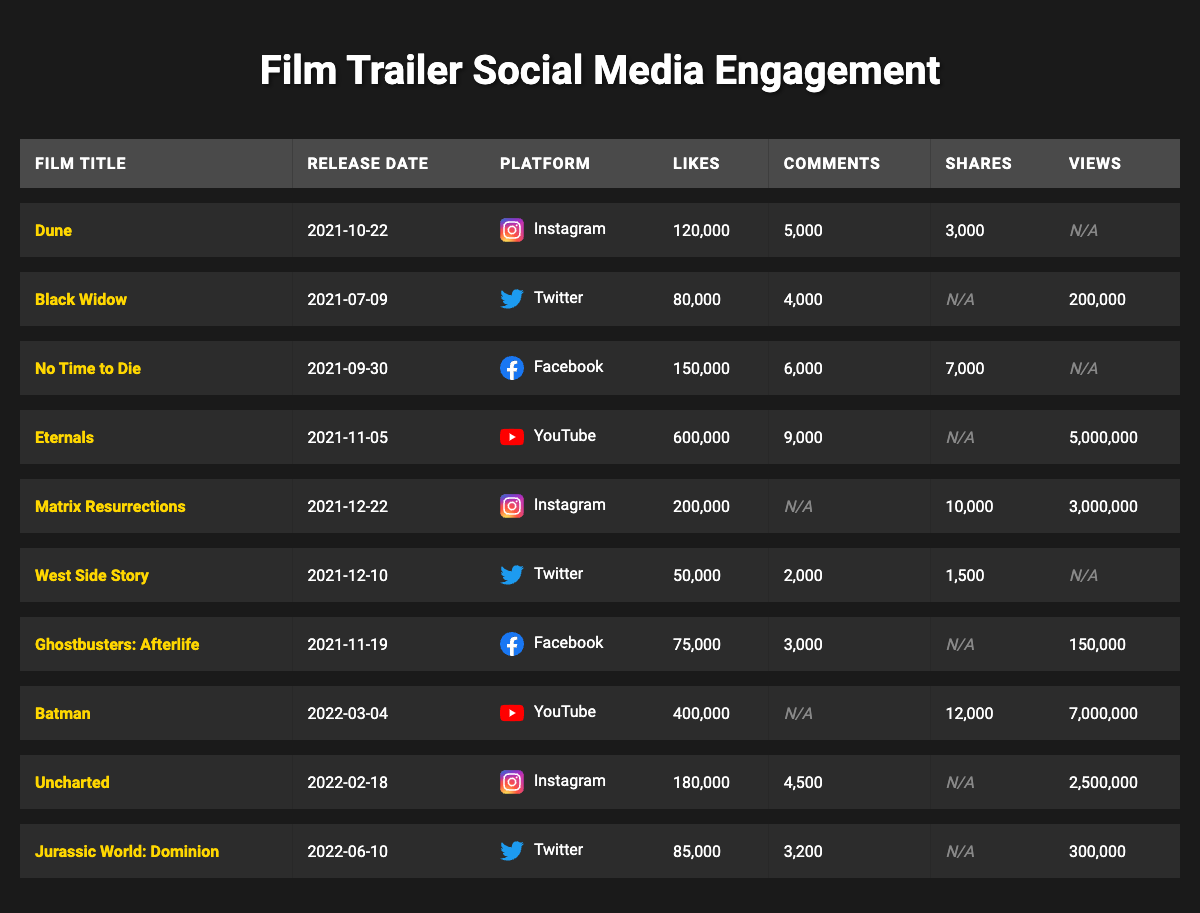What is the platform with the highest number of likes for a film trailer? By examining the 'Likes' column across all platforms, 'Eternals' on YouTube has the highest value at 600,000.
Answer: YouTube How many films had a release date in 2021? Counting the release dates in the table, there are 8 films released in 2021.
Answer: 8 Which film received the most likes on Facebook? From the data, 'No Time to Die' on Facebook has the most likes, totaling 150,000.
Answer: No Time to Die What is the total number of shares for 'Batman'? The shares for 'Batman' total 12,000, as it is the only film listed on YouTube with that value.
Answer: 12,000 Did 'Ghostbusters: Afterlife' receive any shares on social media? According to the data, there are no recorded shares for 'Ghostbusters: Afterlife'; it is marked as null.
Answer: No What is the average number of comments across all trailers? The total number of comments is 5,000 (Dune) + 4,000 (Black Widow) + 6,000 (No Time to Die) + 9,000 (Eternals) + 2,000 (West Side Story) + 3,000 (Ghostbusters: Afterlife) + 4,500 (Uncharted) + 3,200 (Jurassic World: Dominion) = 36,700. There are 8 films, so 36,700 / 8 = 4,587.5.
Answer: 4,587.5 Which film had the lowest number of likes on Twitter? Looking at the likes column for Twitter, 'West Side Story' has the lowest likes with 50,000.
Answer: West Side Story How many views did 'Matrix Resurrections' receive? 'Matrix Resurrections' received 3,000,000 views as listed in the table.
Answer: 3,000,000 Are there any films that showed null values for comments? Yes, both 'Matrix Resurrections' and 'Batman' have null values for comments in the table.
Answer: Yes What is the difference in likes between 'Dune' and 'Black Widow'? The number of likes for 'Dune' is 120,000 and for 'Black Widow' is 80,000. The difference is 120,000 - 80,000 = 40,000.
Answer: 40,000 What percentage of the total shares are accounted for by 'Matrix Resurrections'? The total shares of all films are: 3,000 (Dune) + 0 (Black Widow) + 7,000 (No Time to Die) + 0 (Eternals) + 10,000 (Matrix Resurrections) + 1,500 (West Side Story) + 0 (Ghostbusters: Afterlife) + 12,000 (Batman) + 0 (Uncharted) + 0 (Jurassic World: Dominion) = 33,500. For 'Matrix Resurrections': (10,000 / 33,500) * 100 = 29.85%.
Answer: 29.85% 